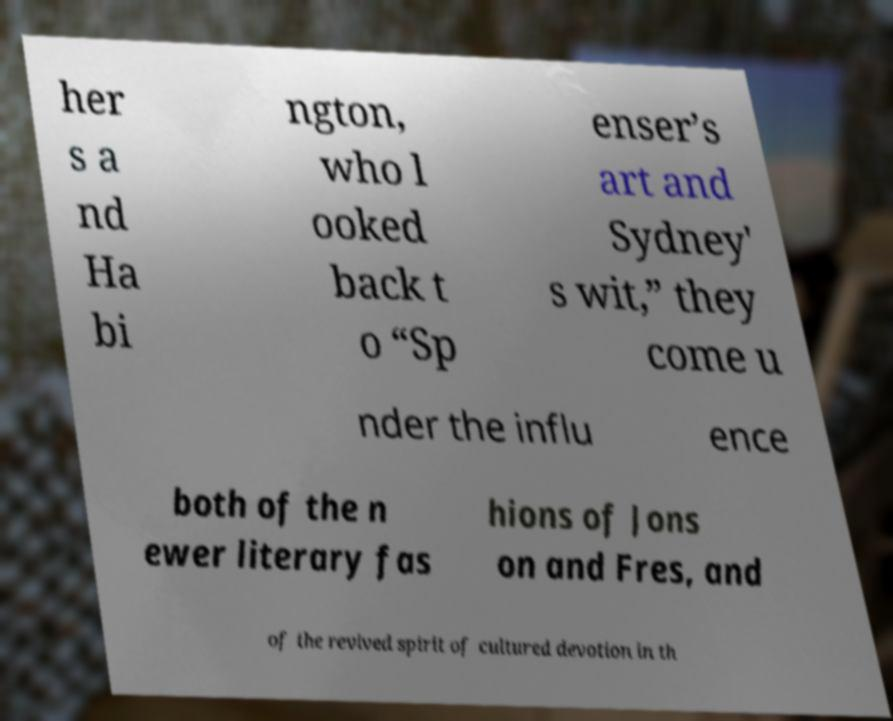Can you accurately transcribe the text from the provided image for me? her s a nd Ha bi ngton, who l ooked back t o “Sp enser’s art and Sydney' s wit,” they come u nder the influ ence both of the n ewer literary fas hions of Jons on and Fres, and of the revived spirit of cultured devotion in th 